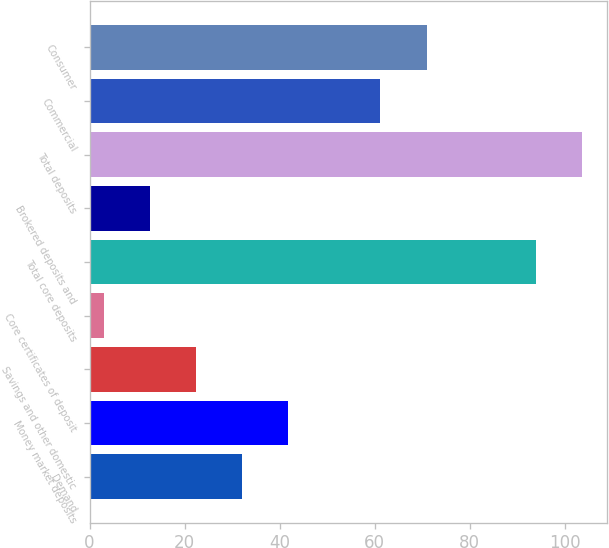<chart> <loc_0><loc_0><loc_500><loc_500><bar_chart><fcel>Demand<fcel>Money market deposits<fcel>Savings and other domestic<fcel>Core certificates of deposit<fcel>Total core deposits<fcel>Brokered deposits and<fcel>Total deposits<fcel>Commercial<fcel>Consumer<nl><fcel>32.1<fcel>41.8<fcel>22.4<fcel>3<fcel>94<fcel>12.7<fcel>103.7<fcel>61.2<fcel>70.9<nl></chart> 